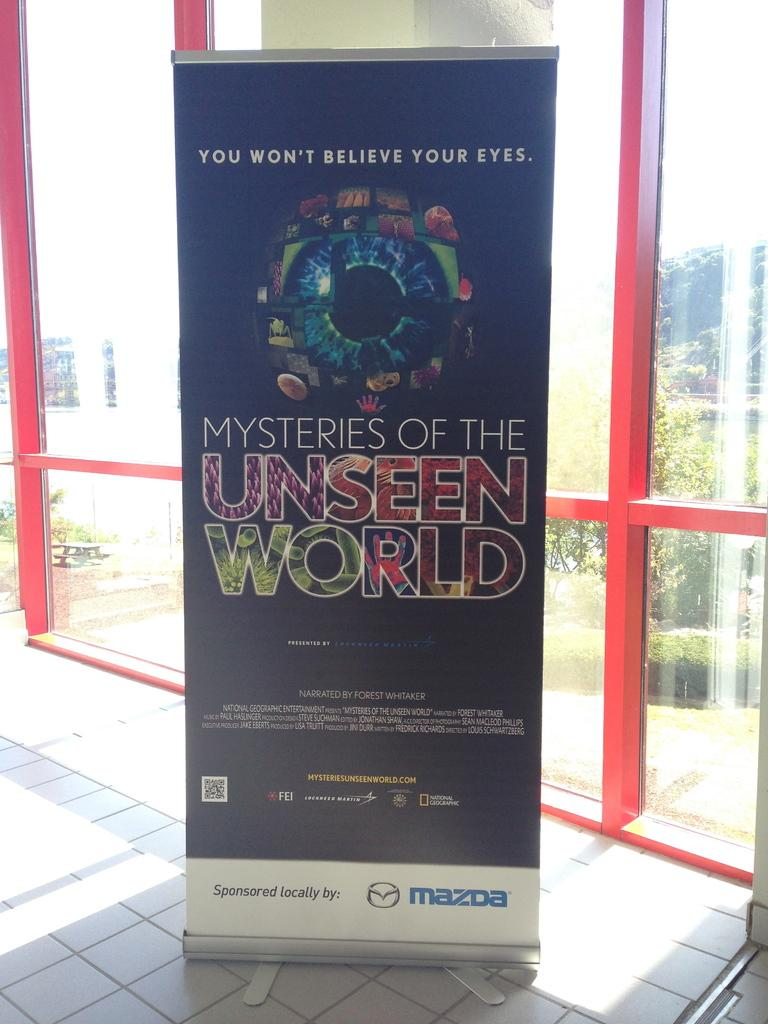<image>
Share a concise interpretation of the image provided. An advertisement displays an eyeball and is sponsored by Mazda. 